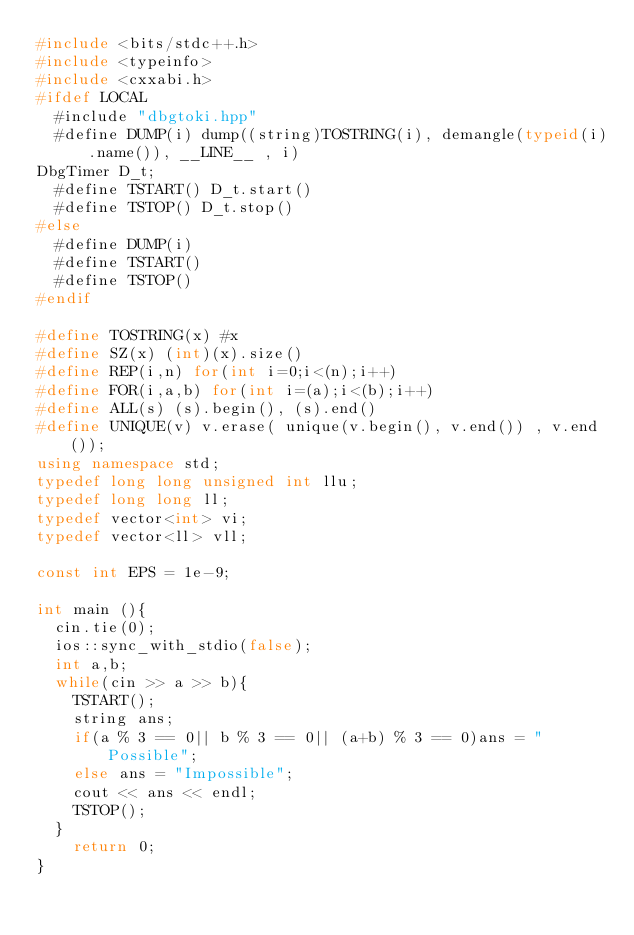Convert code to text. <code><loc_0><loc_0><loc_500><loc_500><_C++_>#include <bits/stdc++.h>
#include <typeinfo>
#include <cxxabi.h>
#ifdef LOCAL
  #include "dbgtoki.hpp"
  #define DUMP(i) dump((string)TOSTRING(i), demangle(typeid(i).name()), __LINE__ , i) 
DbgTimer D_t;
  #define TSTART() D_t.start()
  #define TSTOP() D_t.stop()
#else
  #define DUMP(i) 
  #define TSTART()
  #define TSTOP()  
#endif
 
#define TOSTRING(x) #x
#define SZ(x) (int)(x).size()
#define REP(i,n) for(int i=0;i<(n);i++)
#define FOR(i,a,b) for(int i=(a);i<(b);i++)
#define ALL(s) (s).begin(), (s).end()
#define UNIQUE(v) v.erase( unique(v.begin(), v.end()) , v.end());
using namespace std;
typedef long long unsigned int llu;
typedef long long ll;
typedef vector<int> vi;
typedef vector<ll> vll;

const int EPS = 1e-9;

int main (){
  cin.tie(0);
  ios::sync_with_stdio(false);
  int a,b;
  while(cin >> a >> b){
    TSTART();
    string ans;
    if(a % 3 == 0|| b % 3 == 0|| (a+b) % 3 == 0)ans = "Possible";
    else ans = "Impossible";
    cout << ans << endl;
    TSTOP();
  }
    return 0;
}

</code> 